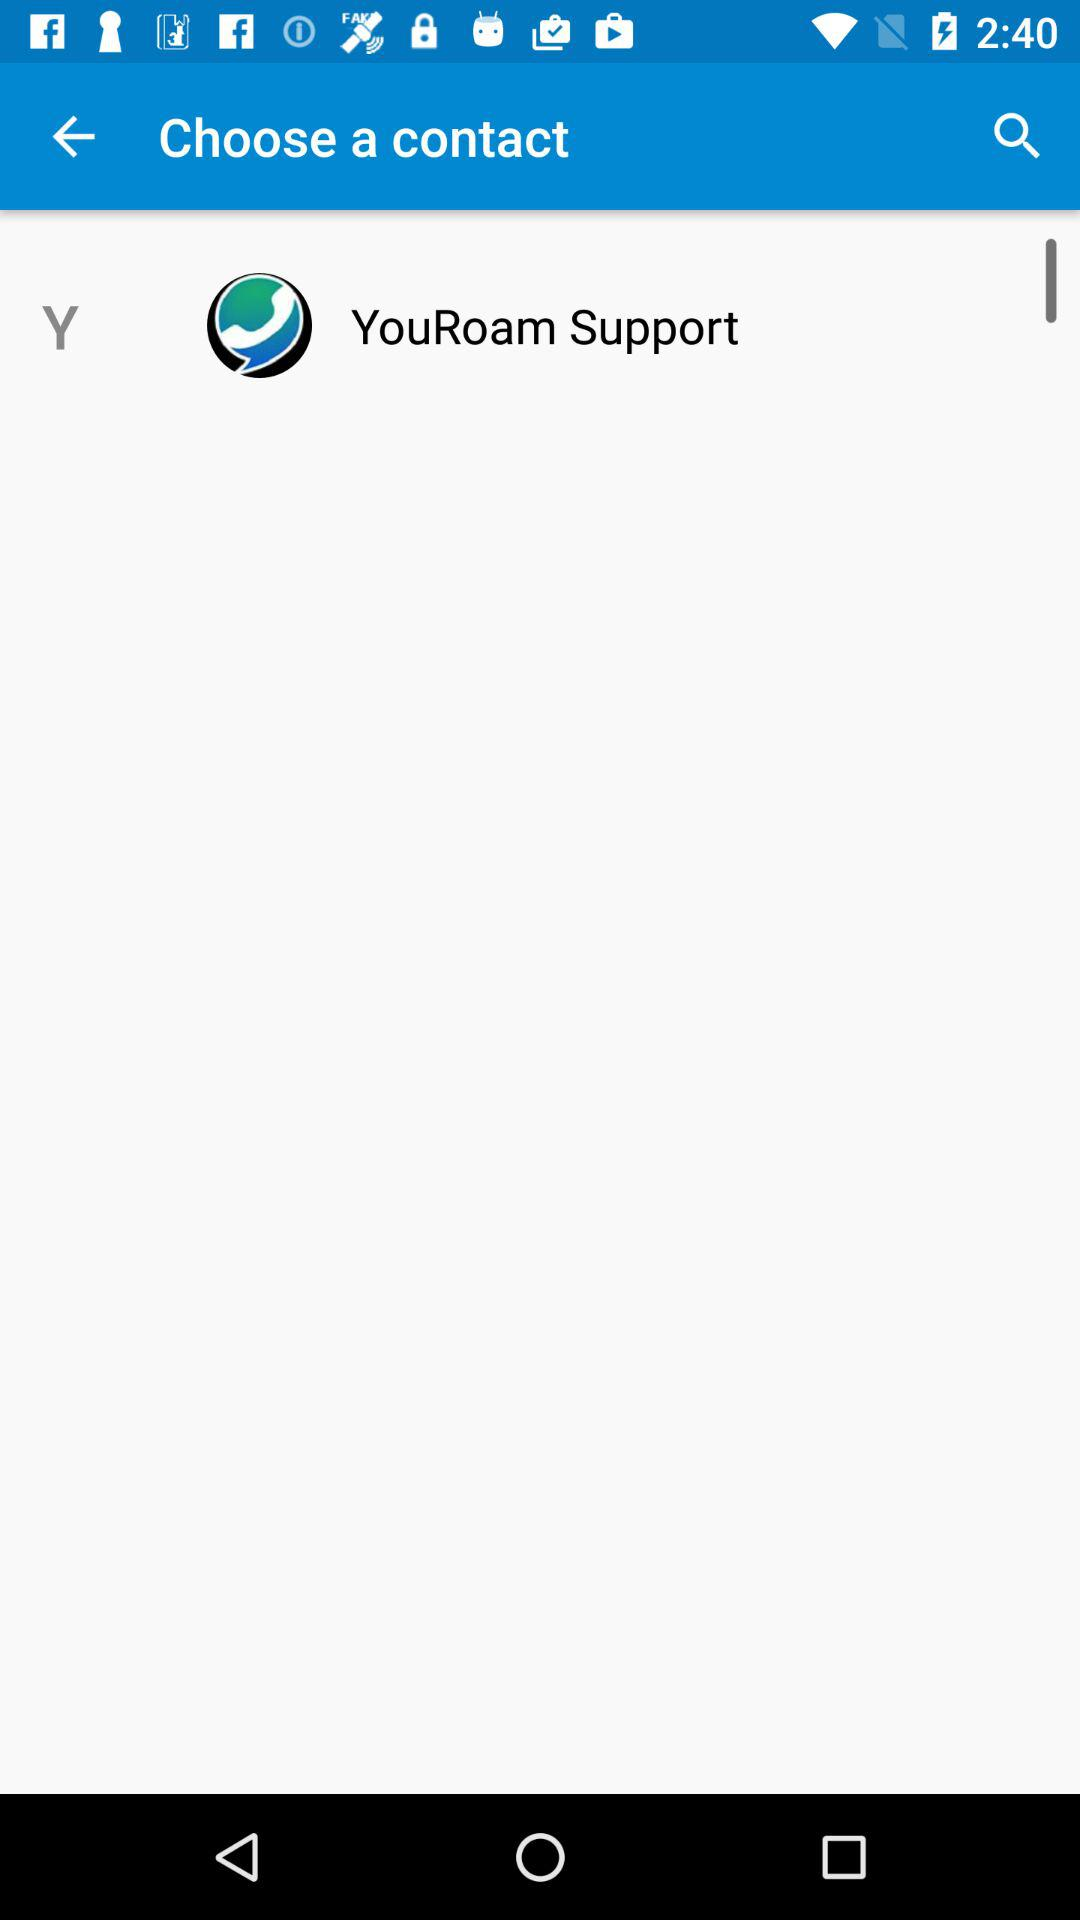What is the contact name? The contact name is "YouRoam Support". 